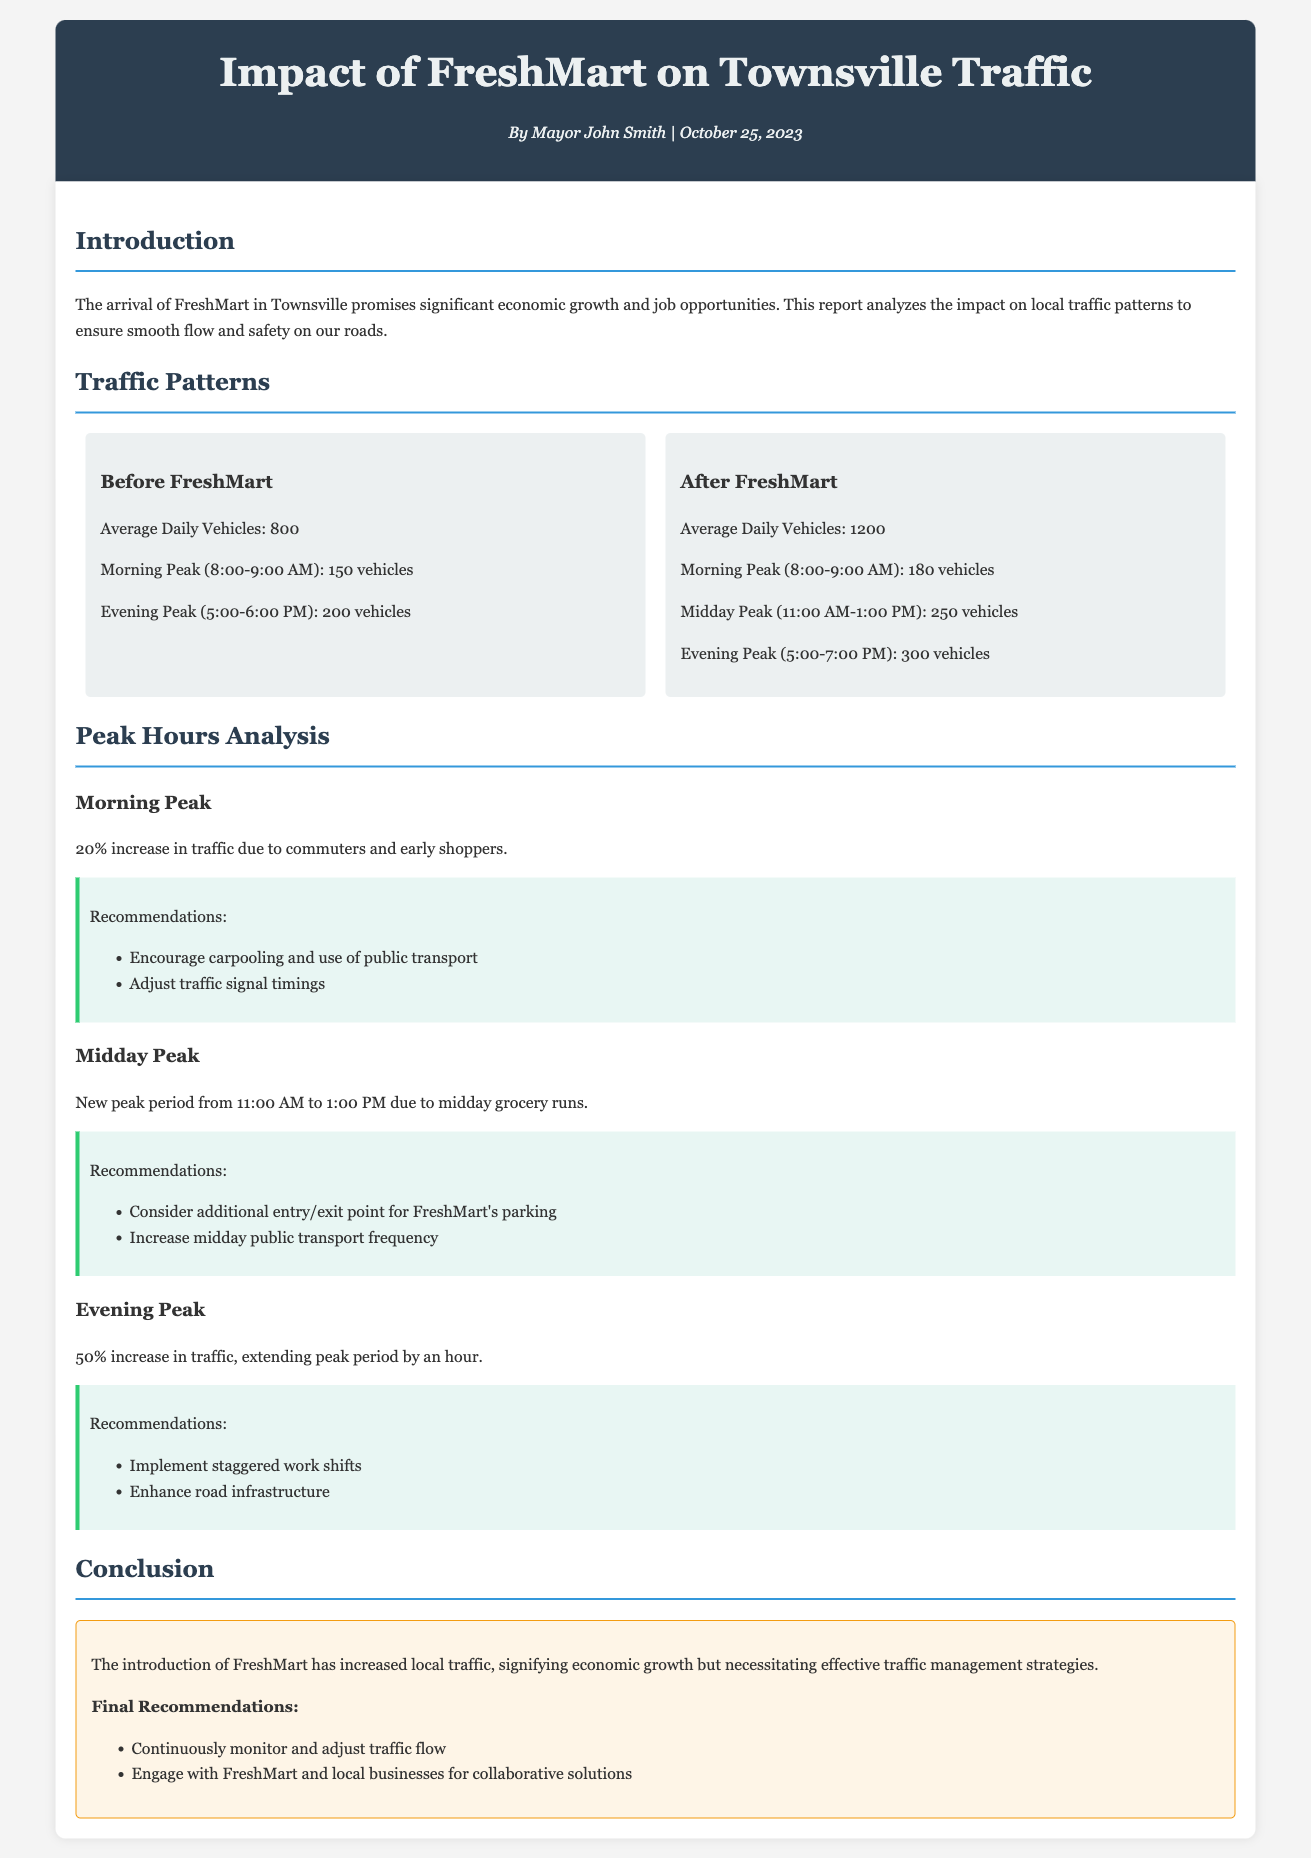What is the average daily number of vehicles after FreshMart? The document states the average daily vehicles after FreshMart is 1200.
Answer: 1200 What is the percentage increase in morning peak traffic? The document indicates a 20% increase in traffic during the morning peak due to FreshMart.
Answer: 20% What time frame constitutes the evening peak after FreshMart? The document specifies that the evening peak time is from 5:00 to 7:00 PM after FreshMart's arrival.
Answer: 5:00-7:00 PM What happens to the midday traffic pattern after FreshMart opens? The report highlights a new peak period from 11:00 AM to 1:00 PM, indicating an increase in midday grocery runs.
Answer: New peak period What is the main recommendation for evening peak traffic? The document recommends implementing staggered work shifts to manage the increased evening traffic flow.
Answer: Staggered work shifts What was the average daily vehicle count before FreshMart? The document states the average daily vehicles before FreshMart was 800.
Answer: 800 How many vehicles were recorded during the midday peak? After FreshMart, the midday peak recorded 250 vehicles according to the report.
Answer: 250 What is the conclusion regarding FreshMart's impact on local traffic? The conclusion notes that FreshMart has increased local traffic, requiring effective traffic management strategies.
Answer: Increased local traffic 